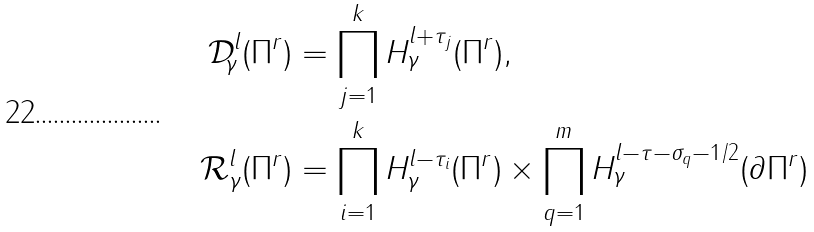Convert formula to latex. <formula><loc_0><loc_0><loc_500><loc_500>\mathcal { D } _ { \gamma } ^ { l } ( \Pi ^ { r } ) & = \prod _ { j = 1 } ^ { k } H _ { \gamma } ^ { l + \tau _ { j } } ( \Pi ^ { r } ) , \\ \mathcal { R } _ { \gamma } ^ { l } ( \Pi ^ { r } ) & = \prod _ { i = 1 } ^ { k } H _ { \gamma } ^ { l - \tau _ { i } } ( \Pi ^ { r } ) \times \prod _ { q = 1 } ^ { m } H _ { \gamma } ^ { l - \tau - \sigma _ { q } - 1 / 2 } ( \partial \Pi ^ { r } )</formula> 